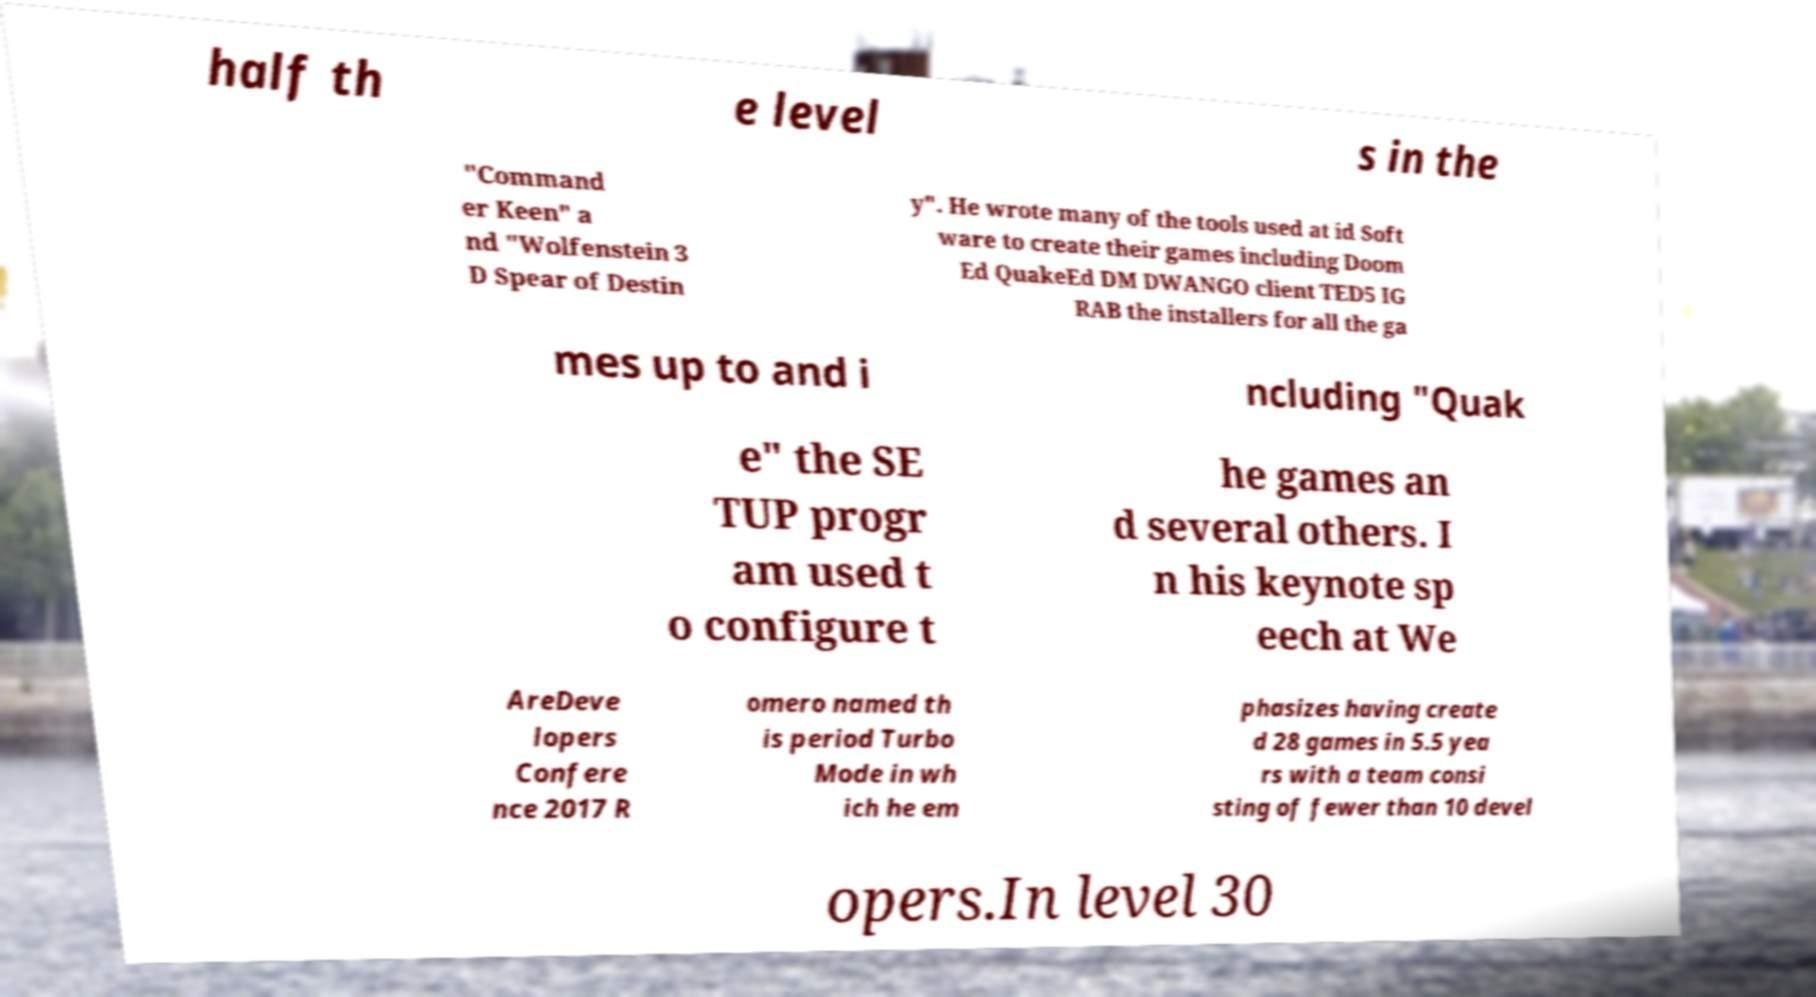There's text embedded in this image that I need extracted. Can you transcribe it verbatim? half th e level s in the "Command er Keen" a nd "Wolfenstein 3 D Spear of Destin y". He wrote many of the tools used at id Soft ware to create their games including Doom Ed QuakeEd DM DWANGO client TED5 IG RAB the installers for all the ga mes up to and i ncluding "Quak e" the SE TUP progr am used t o configure t he games an d several others. I n his keynote sp eech at We AreDeve lopers Confere nce 2017 R omero named th is period Turbo Mode in wh ich he em phasizes having create d 28 games in 5.5 yea rs with a team consi sting of fewer than 10 devel opers.In level 30 